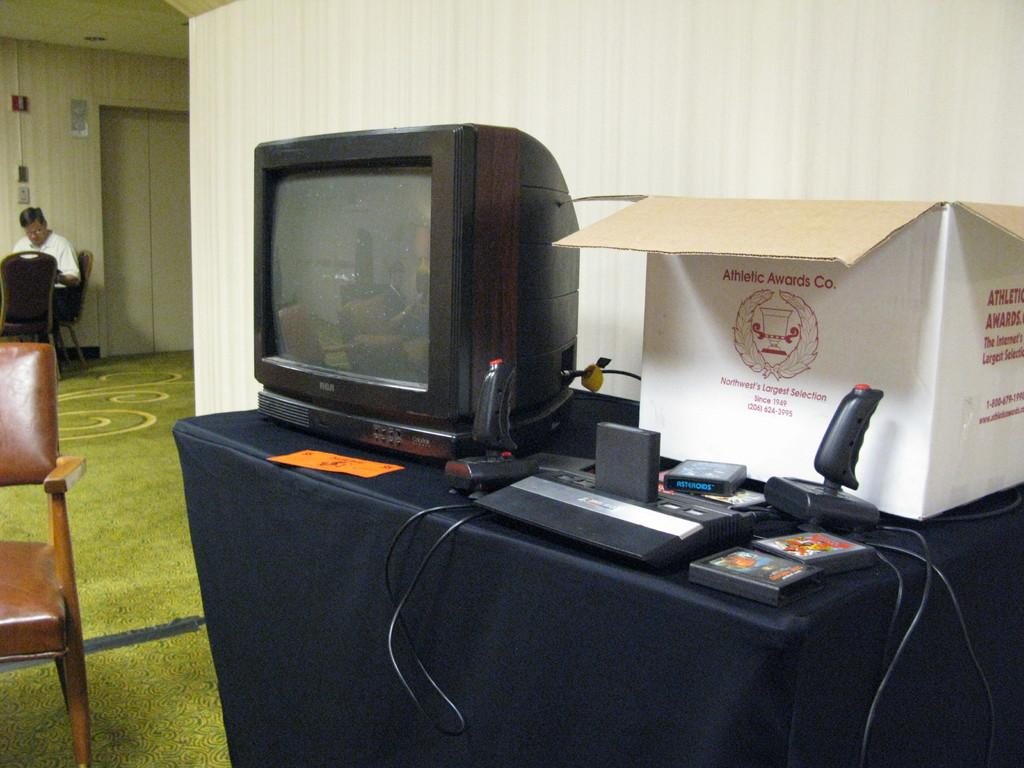<image>
Offer a succinct explanation of the picture presented. An old black TV is on a desk next to a game console, two joysticks, and a white box that says Athletic Awards Co. 